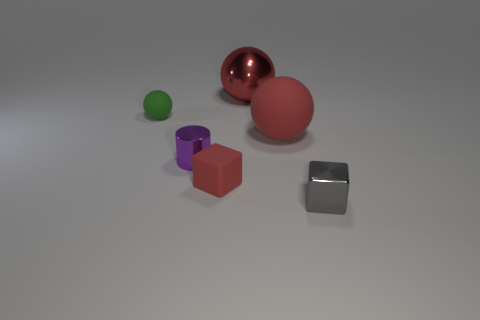Does the gray shiny object have the same shape as the tiny green rubber thing?
Make the answer very short. No. Is there a small purple cylinder that has the same material as the small green sphere?
Ensure brevity in your answer.  No. What color is the object that is right of the big red metal object and behind the purple metallic cylinder?
Ensure brevity in your answer.  Red. What is the material of the ball to the left of the small cylinder?
Your answer should be very brief. Rubber. Are there any big cyan metallic objects of the same shape as the gray thing?
Your answer should be very brief. No. What number of other things are the same shape as the tiny red rubber thing?
Give a very brief answer. 1. There is a tiny red thing; does it have the same shape as the red thing behind the green thing?
Make the answer very short. No. Is there any other thing that is made of the same material as the small cylinder?
Your answer should be very brief. Yes. There is a small gray thing that is the same shape as the small red thing; what is its material?
Offer a terse response. Metal. How many small objects are purple rubber spheres or spheres?
Your answer should be very brief. 1. 